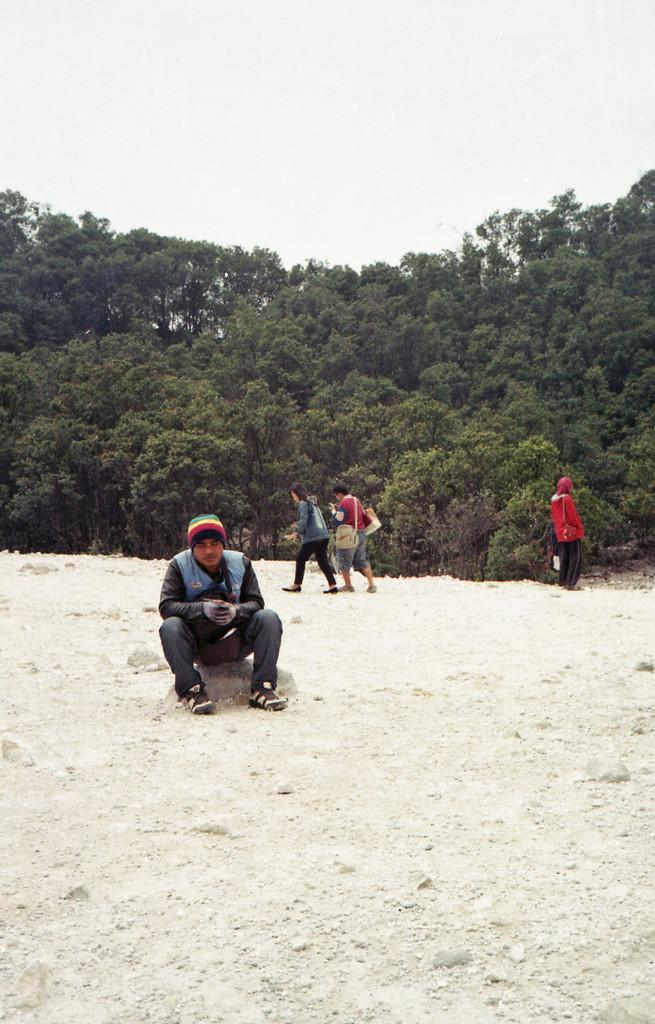Who or what is present in the image? There are people in the image. What type of surface can be seen beneath the people? There is ground visible in the image. What type of vegetation is present in the image? There are trees in the image. What can be seen in the distance in the image? The sky is visible in the background of the image. Can you see a key hanging from one of the trees in the image? There is no key present in the image; only people, ground, trees, and the sky are visible. 